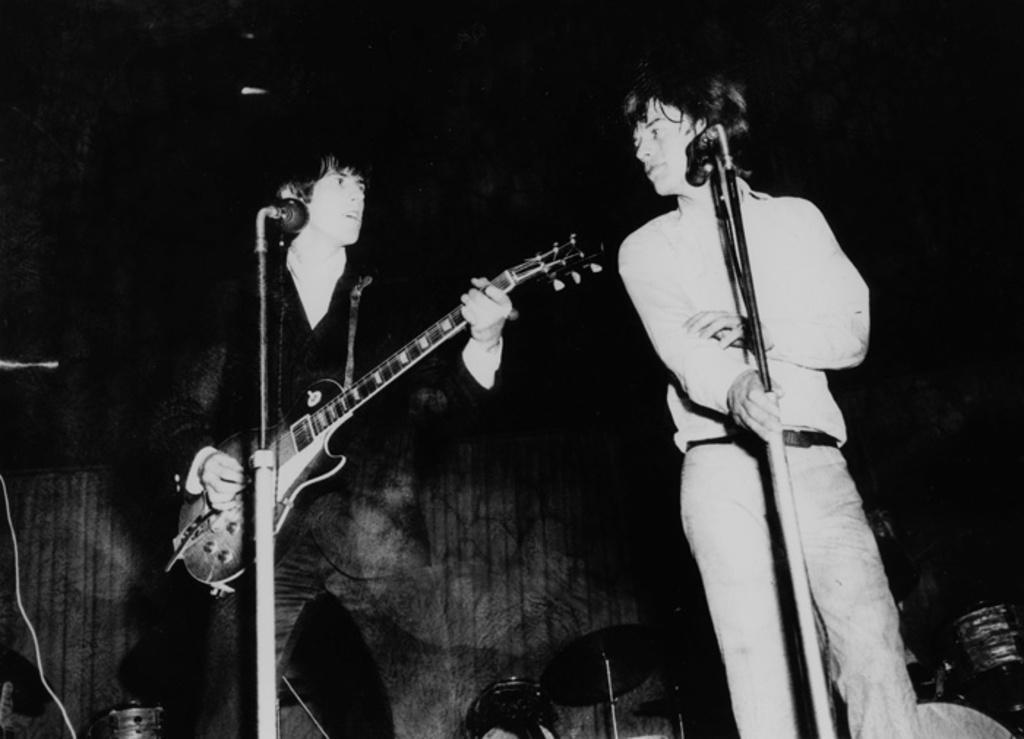Describe this image in one or two sentences. This picture shows two men standing and a man holding a guitar in his hand and we see two microphones in front of them 